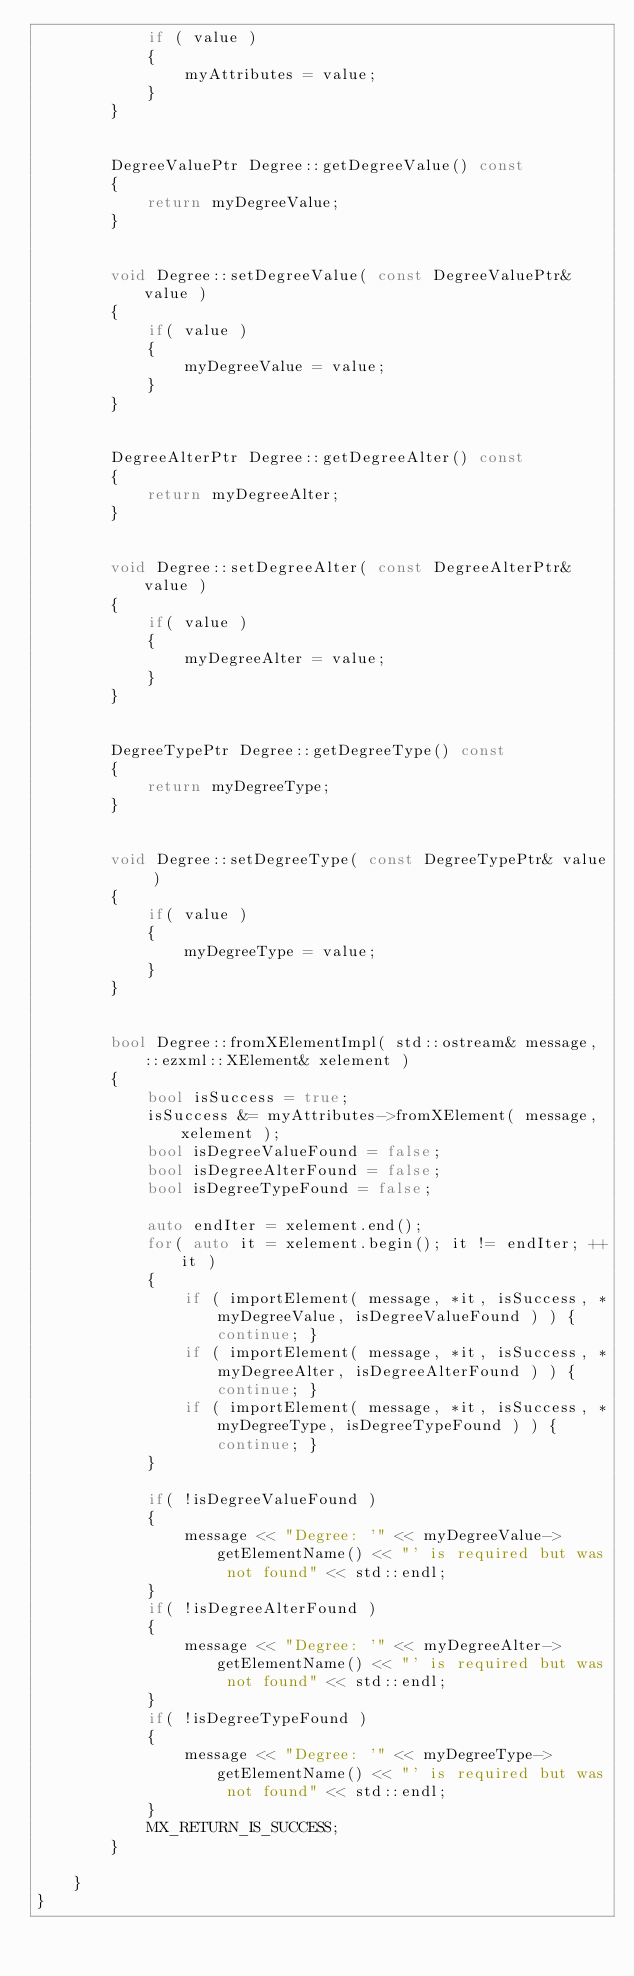<code> <loc_0><loc_0><loc_500><loc_500><_C++_>            if ( value )
            {
                myAttributes = value;
            }
        }


        DegreeValuePtr Degree::getDegreeValue() const
        {
            return myDegreeValue;
        }


        void Degree::setDegreeValue( const DegreeValuePtr& value )
        {
            if( value )
            {
                myDegreeValue = value;
            }
        }


        DegreeAlterPtr Degree::getDegreeAlter() const
        {
            return myDegreeAlter;
        }


        void Degree::setDegreeAlter( const DegreeAlterPtr& value )
        {
            if( value )
            {
                myDegreeAlter = value;
            }
        }


        DegreeTypePtr Degree::getDegreeType() const
        {
            return myDegreeType;
        }


        void Degree::setDegreeType( const DegreeTypePtr& value )
        {
            if( value )
            {
                myDegreeType = value;
            }
        }


        bool Degree::fromXElementImpl( std::ostream& message, ::ezxml::XElement& xelement )
        {
            bool isSuccess = true;
            isSuccess &= myAttributes->fromXElement( message, xelement );
            bool isDegreeValueFound = false;
            bool isDegreeAlterFound = false;
            bool isDegreeTypeFound = false;

            auto endIter = xelement.end();
            for( auto it = xelement.begin(); it != endIter; ++it )
            {
                if ( importElement( message, *it, isSuccess, *myDegreeValue, isDegreeValueFound ) ) { continue; }
                if ( importElement( message, *it, isSuccess, *myDegreeAlter, isDegreeAlterFound ) ) { continue; }
                if ( importElement( message, *it, isSuccess, *myDegreeType, isDegreeTypeFound ) ) { continue; }
            }

            if( !isDegreeValueFound )
            {
                message << "Degree: '" << myDegreeValue->getElementName() << "' is required but was not found" << std::endl;
            }
            if( !isDegreeAlterFound )
            {
                message << "Degree: '" << myDegreeAlter->getElementName() << "' is required but was not found" << std::endl;
            }
            if( !isDegreeTypeFound )
            {
                message << "Degree: '" << myDegreeType->getElementName() << "' is required but was not found" << std::endl;
            }
            MX_RETURN_IS_SUCCESS;
        }

    }
}
</code> 